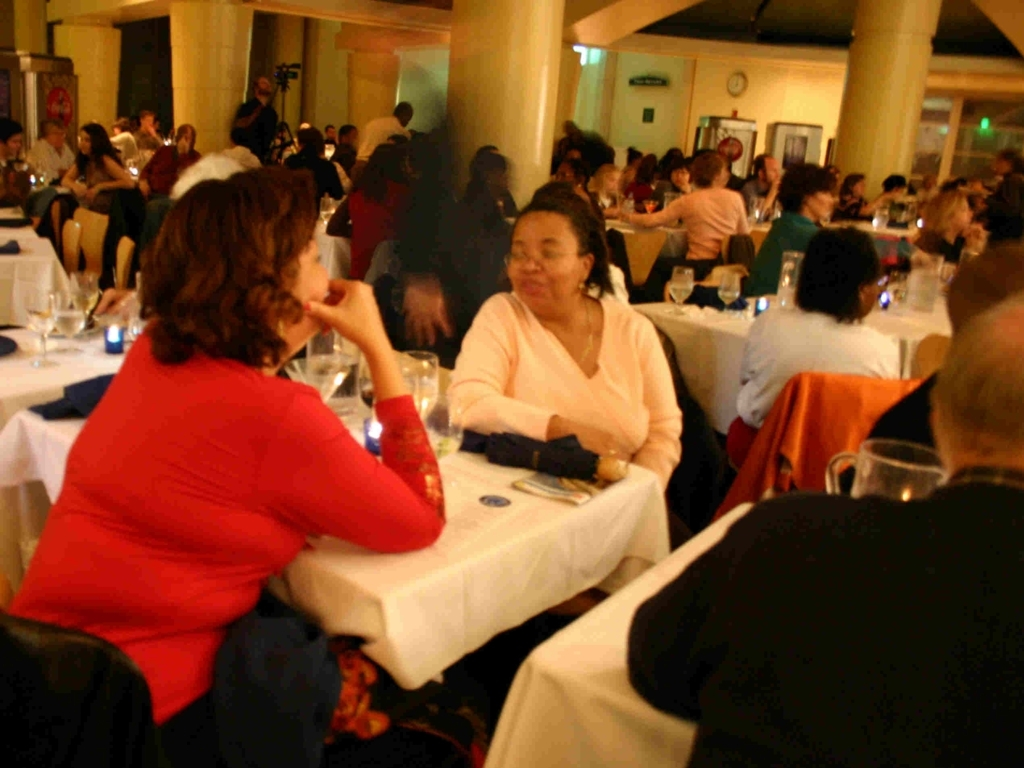What might be the occasion for this gathering? Given the attire of the guests and the setup with tables and dining ware, it suggests that this could be a formal event such as an awards dinner, a wedding reception, or a banquet celebrating a specific occasion. The conviviality visible among the guests indicates it's a festive and significant social event. How can you tell it's a formal event? Judging by the way people are dressed, some can be seen wearing what appears to be evening wear, which is typically chosen for more formal events. Additionally, the organization of the room with cloth-covered tables, glassware, and the general decor suggest that this event was planned with formality in mind. 